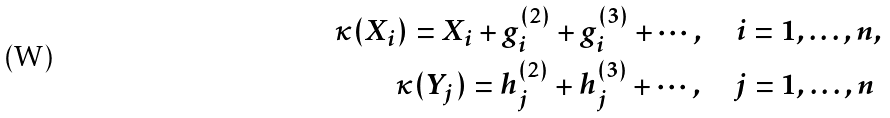<formula> <loc_0><loc_0><loc_500><loc_500>\kappa ( X _ { i } ) = X _ { i } + g ^ { ( 2 ) } _ { i } + g ^ { ( 3 ) } _ { i } + \cdots , \quad i = 1 , \dots , n , \\ \kappa ( Y _ { j } ) = h ^ { ( 2 ) } _ { j } + h ^ { ( 3 ) } _ { j } + \cdots , \quad j = 1 , \dots , n \</formula> 